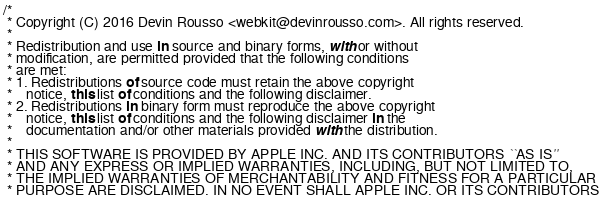Convert code to text. <code><loc_0><loc_0><loc_500><loc_500><_JavaScript_>/*
 * Copyright (C) 2016 Devin Rousso <webkit@devinrousso.com>. All rights reserved.
 *
 * Redistribution and use in source and binary forms, with or without
 * modification, are permitted provided that the following conditions
 * are met:
 * 1. Redistributions of source code must retain the above copyright
 *    notice, this list of conditions and the following disclaimer.
 * 2. Redistributions in binary form must reproduce the above copyright
 *    notice, this list of conditions and the following disclaimer in the
 *    documentation and/or other materials provided with the distribution.
 *
 * THIS SOFTWARE IS PROVIDED BY APPLE INC. AND ITS CONTRIBUTORS ``AS IS''
 * AND ANY EXPRESS OR IMPLIED WARRANTIES, INCLUDING, BUT NOT LIMITED TO,
 * THE IMPLIED WARRANTIES OF MERCHANTABILITY AND FITNESS FOR A PARTICULAR
 * PURPOSE ARE DISCLAIMED. IN NO EVENT SHALL APPLE INC. OR ITS CONTRIBUTORS</code> 